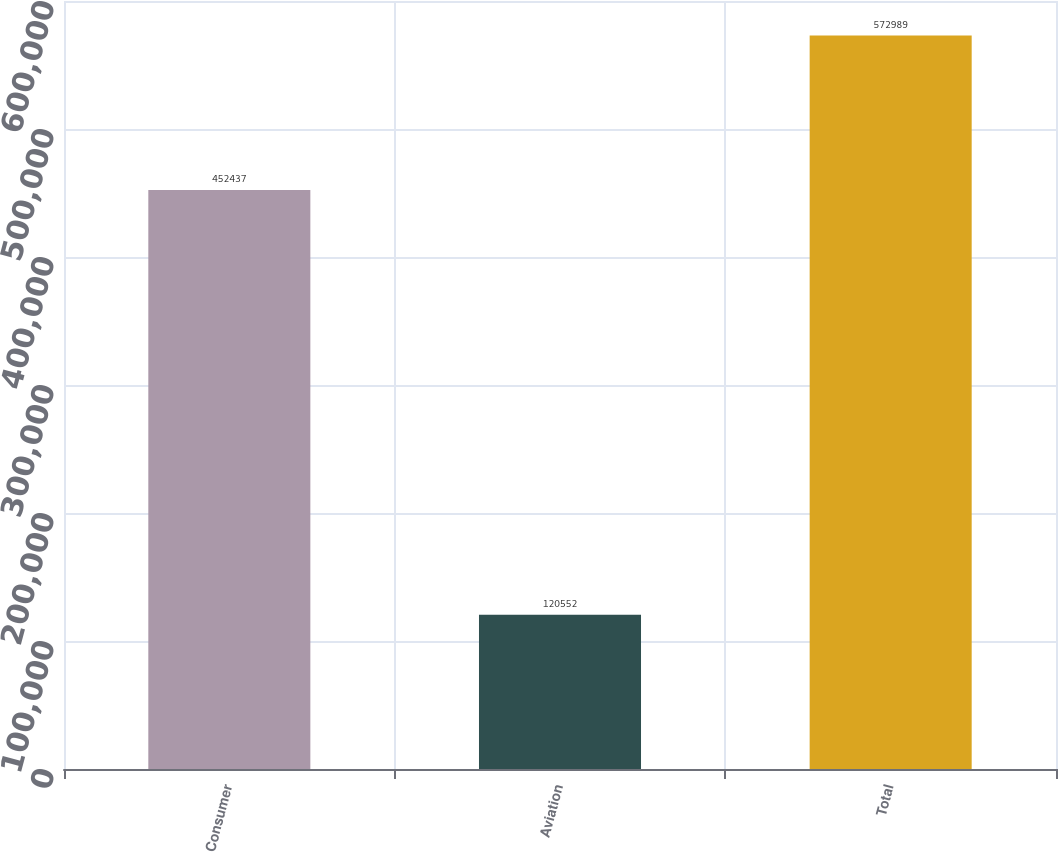Convert chart to OTSL. <chart><loc_0><loc_0><loc_500><loc_500><bar_chart><fcel>Consumer<fcel>Aviation<fcel>Total<nl><fcel>452437<fcel>120552<fcel>572989<nl></chart> 